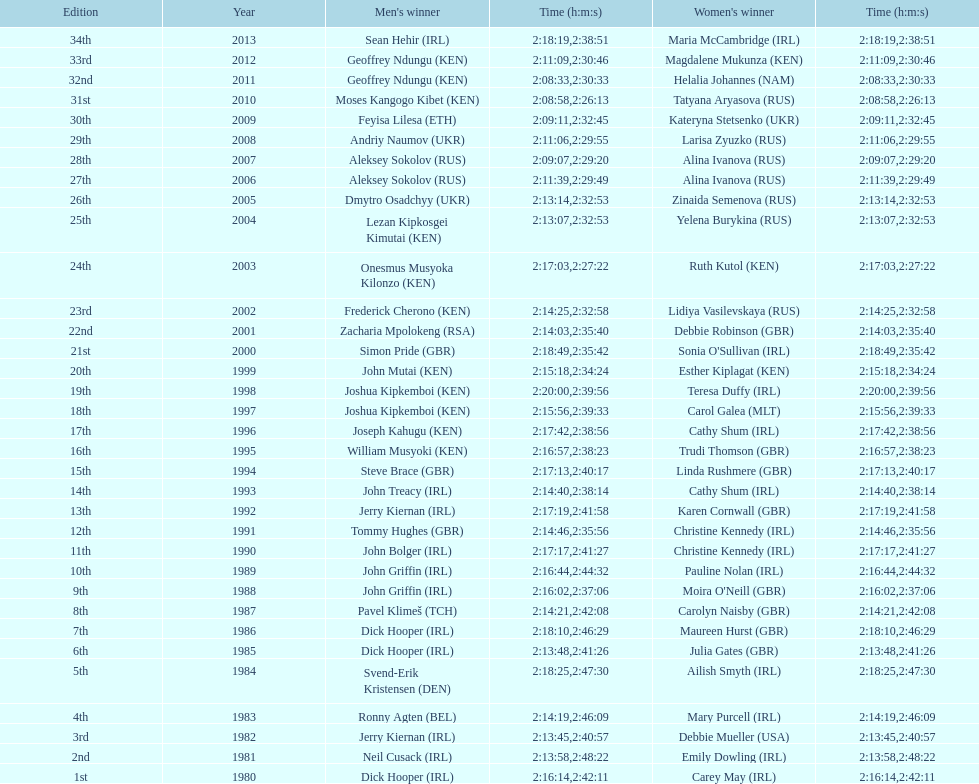Who won after joseph kipkemboi's winning streak ended? John Mutai (KEN). 